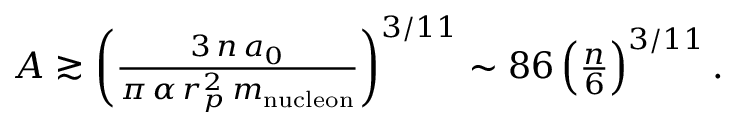Convert formula to latex. <formula><loc_0><loc_0><loc_500><loc_500>\begin{array} { r } { A \gtrsim \left ( \frac { 3 \, n \, a _ { 0 } } { \pi \, \alpha \, r _ { p } ^ { 2 } \, m _ { n u c l e o n } } \right ) ^ { 3 / 1 1 } \sim 8 6 \left ( \frac { n } { 6 } \right ) ^ { 3 / 1 1 } . } \end{array}</formula> 